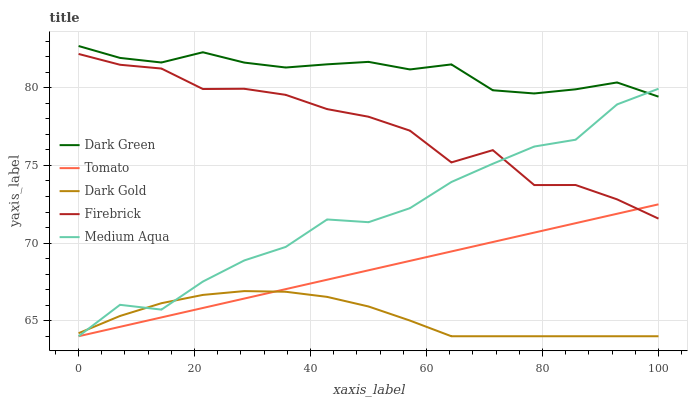Does Dark Gold have the minimum area under the curve?
Answer yes or no. Yes. Does Dark Green have the maximum area under the curve?
Answer yes or no. Yes. Does Firebrick have the minimum area under the curve?
Answer yes or no. No. Does Firebrick have the maximum area under the curve?
Answer yes or no. No. Is Tomato the smoothest?
Answer yes or no. Yes. Is Firebrick the roughest?
Answer yes or no. Yes. Is Dark Gold the smoothest?
Answer yes or no. No. Is Dark Gold the roughest?
Answer yes or no. No. Does Tomato have the lowest value?
Answer yes or no. Yes. Does Firebrick have the lowest value?
Answer yes or no. No. Does Dark Green have the highest value?
Answer yes or no. Yes. Does Firebrick have the highest value?
Answer yes or no. No. Is Dark Gold less than Dark Green?
Answer yes or no. Yes. Is Firebrick greater than Dark Gold?
Answer yes or no. Yes. Does Medium Aqua intersect Dark Gold?
Answer yes or no. Yes. Is Medium Aqua less than Dark Gold?
Answer yes or no. No. Is Medium Aqua greater than Dark Gold?
Answer yes or no. No. Does Dark Gold intersect Dark Green?
Answer yes or no. No. 